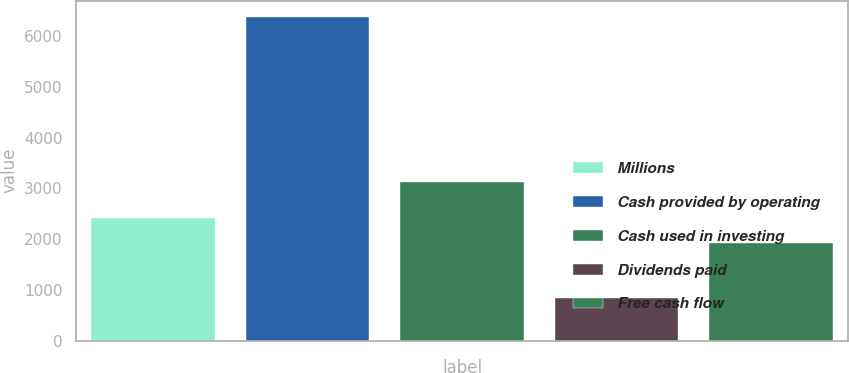Convert chart. <chart><loc_0><loc_0><loc_500><loc_500><bar_chart><fcel>Millions<fcel>Cash provided by operating<fcel>Cash used in investing<fcel>Dividends paid<fcel>Free cash flow<nl><fcel>2420.6<fcel>6376.6<fcel>3119<fcel>837<fcel>1917<nl></chart> 